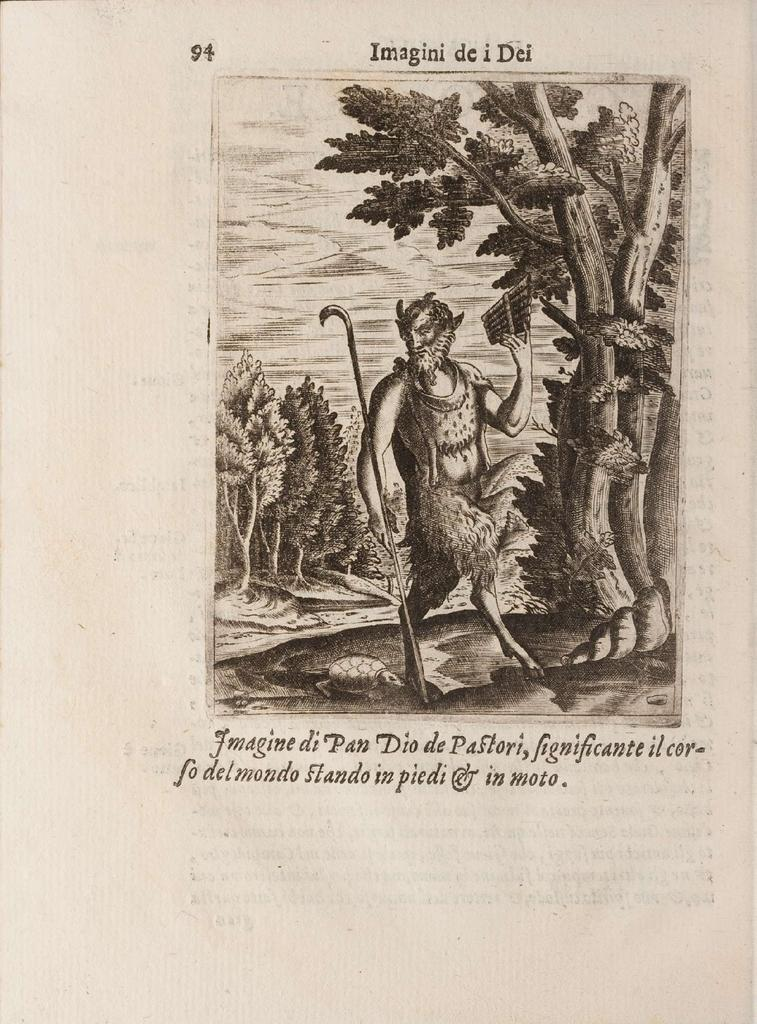What is present in the image that contains information or a message? There is a poster in the image. What can be found on the poster? The poster has text on it. How many trees are depicted on the poster in the image? There is no mention of trees on the poster in the image, as the facts only state that the poster has text on it. 